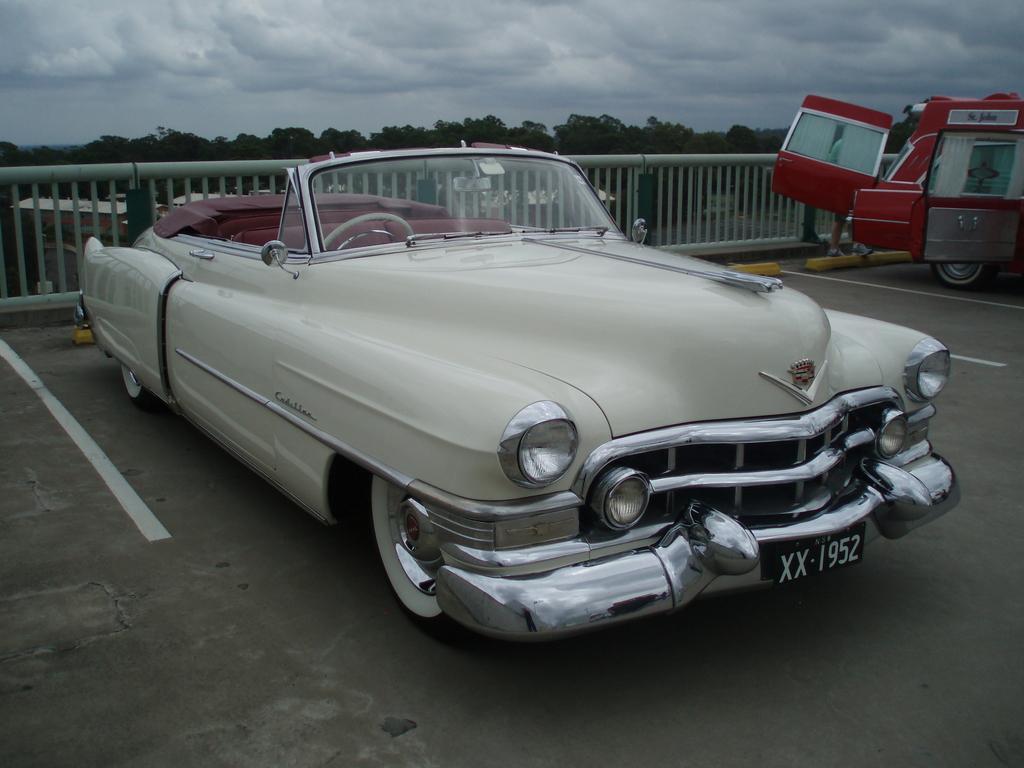Could you give a brief overview of what you see in this image? In this image I can see two vehicles which are in white and red color. These vehicles are to the side of the railing. And I can see the number plate to the side of the vehicle. In the background there are many trees, clouds and the sky. 